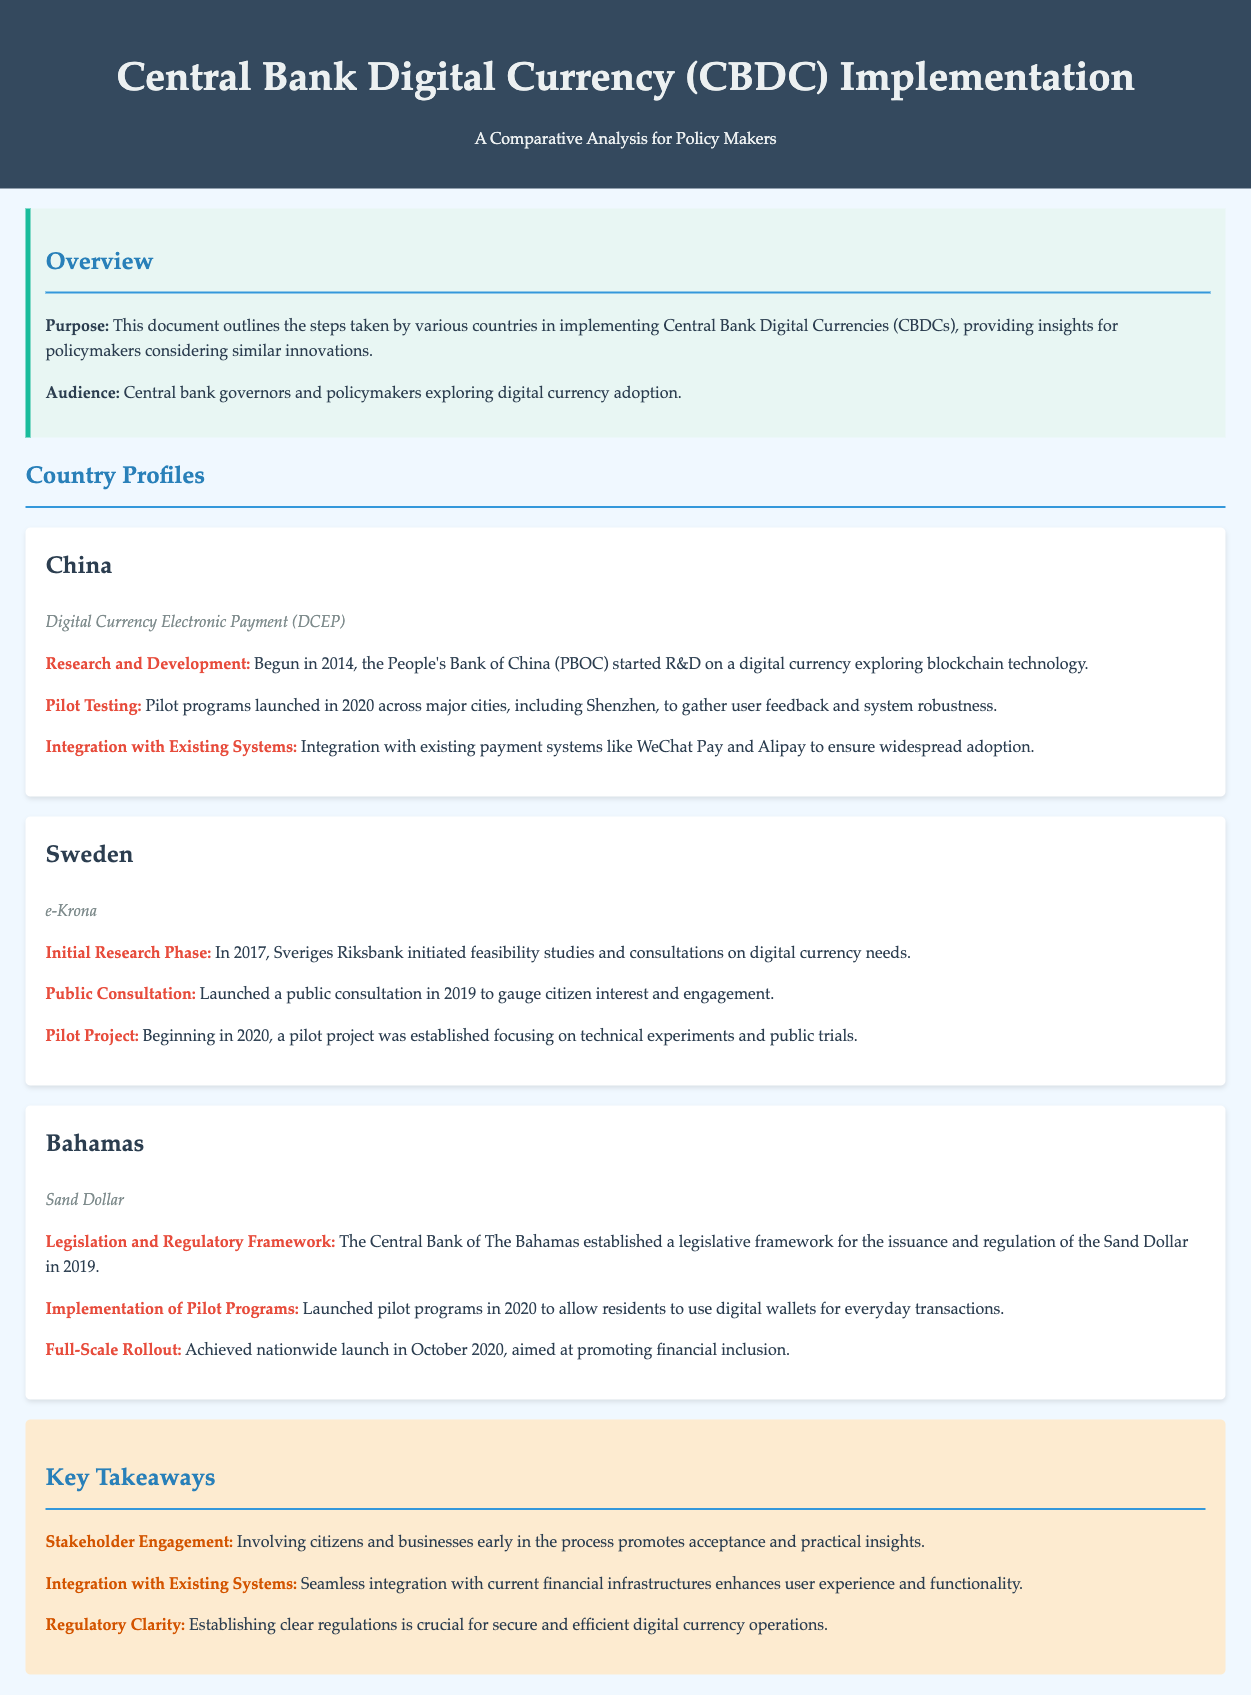What is the name of China's CBDC? The document lists the name of China’s CBDC as "Digital Currency Electronic Payment (DCEP)."
Answer: Digital Currency Electronic Payment (DCEP) What year did China's research on digital currency begin? The document states that China's research and development on digital currency began in 2014.
Answer: 2014 What was the public consultation year for Sweden's CBDC? The document indicates that Sweden launched a public consultation in 2019.
Answer: 2019 What is the name of the Bahamas' CBDC? The document mentions that the Bahamas' CBDC is called "Sand Dollar."
Answer: Sand Dollar What key element enhances user experience according to the key takeaways? The document emphasizes that "Integration with Existing Systems" enhances user experience and functionality.
Answer: Integration with Existing Systems In which year did the Bahamas achieve full-scale rollout of Sand Dollar? The document indicates that the full-scale rollout of Sand Dollar occurred in October 2020.
Answer: October 2020 What is the focus of Sweden's pilot project? The document states that Sweden's pilot project focuses on "technical experiments and public trials."
Answer: technical experiments and public trials What was one requirement for secure digital currency operations cited in the key takeaways? The document cites "Regulatory Clarity" as crucial for secure and efficient digital currency operations.
Answer: Regulatory Clarity 